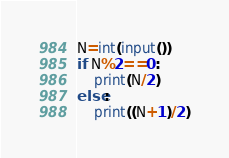Convert code to text. <code><loc_0><loc_0><loc_500><loc_500><_Python_>N=int(input())
if N%2==0:
    print(N/2)
else:
    print((N+1)/2)</code> 